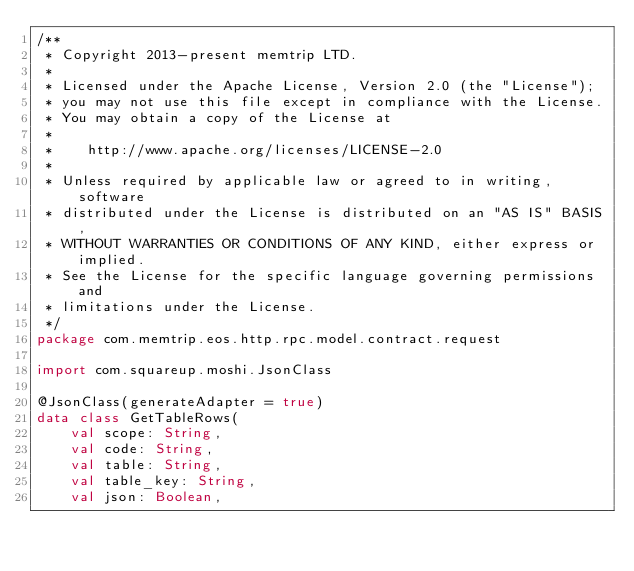Convert code to text. <code><loc_0><loc_0><loc_500><loc_500><_Kotlin_>/**
 * Copyright 2013-present memtrip LTD.
 *
 * Licensed under the Apache License, Version 2.0 (the "License");
 * you may not use this file except in compliance with the License.
 * You may obtain a copy of the License at
 *
 *    http://www.apache.org/licenses/LICENSE-2.0
 *
 * Unless required by applicable law or agreed to in writing, software
 * distributed under the License is distributed on an "AS IS" BASIS,
 * WITHOUT WARRANTIES OR CONDITIONS OF ANY KIND, either express or implied.
 * See the License for the specific language governing permissions and
 * limitations under the License.
 */
package com.memtrip.eos.http.rpc.model.contract.request

import com.squareup.moshi.JsonClass

@JsonClass(generateAdapter = true)
data class GetTableRows(
    val scope: String,
    val code: String,
    val table: String,
    val table_key: String,
    val json: Boolean,</code> 